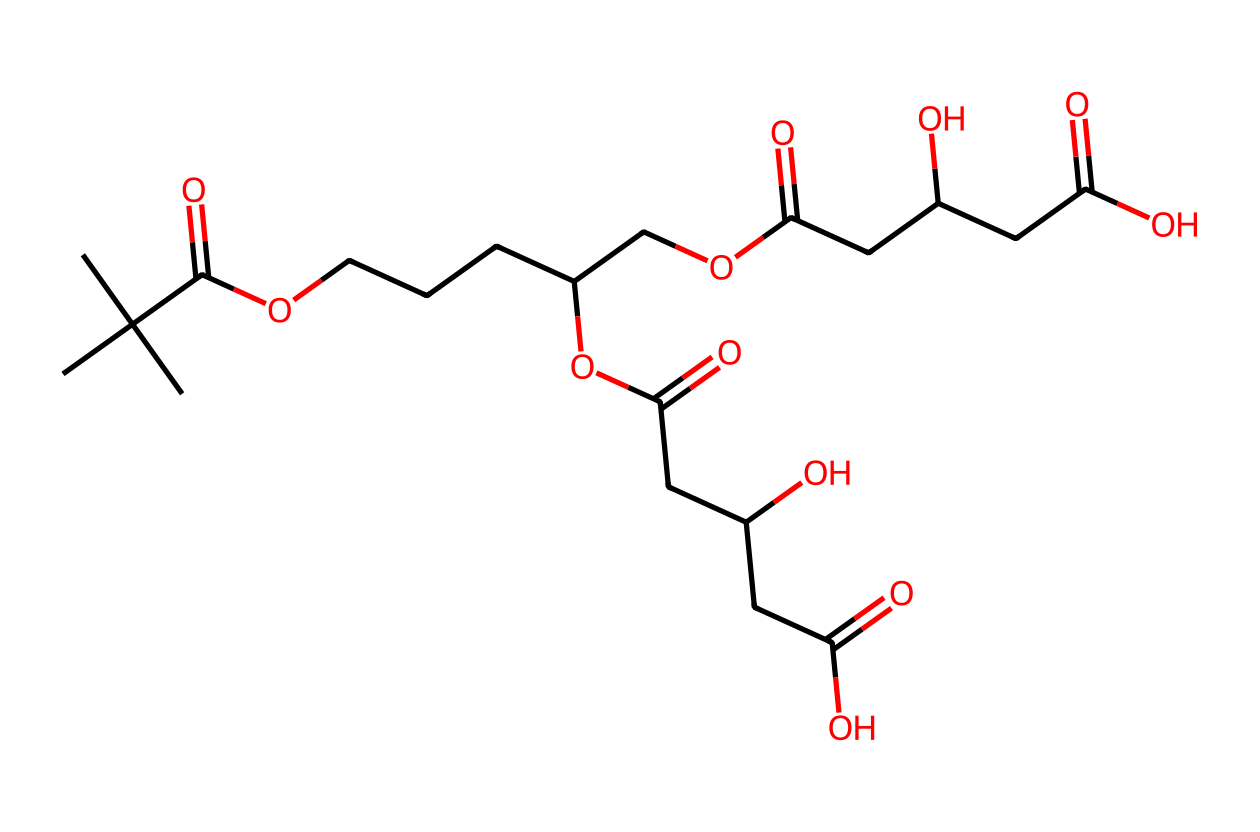What is the molecular formula deduced from the SMILES representation? To determine the molecular formula, count the number of carbon (C), hydrogen (H), and oxygen (O) atoms in the SMILES string. The structure indicates 36 carbons, 66 hydrogens, and 6 oxygens, leading to the formula C36H66O6.
Answer: C36H66O6 How many ester functional groups are present in the molecule? In the SMILES string, the ester groups are indicated by the presence of carbonyl (C=O) adjacent to an ether linkage (O). By examining the structure, there are three ester groups associated with the carbon chains.
Answer: 3 What type of lipid does this chemical represent? The structure shows long carbon chains with ester groups, characterizing it as a triglyceride, a common type of lipid.
Answer: triglyceride How many chiral centers are present in this lipid structure? Chiral centers are carbon atoms bound to four different substituents. Counting the chiral centers in the structure reveals there are four distinct chiral centers within the chains.
Answer: 4 What is the function of lipids in biodegradable packaging? Lipids serve as a hydrophobic barrier and enhance flexibility in packaging materials; they provide structure and stability while being environmentally friendly.
Answer: barrier Which part of the molecule contributes to its biodegradability? The presence of ester bonds and the backbone of long-chain fatty acids play a significant role in enabling microbial degradation, thus contributing to biodegradability.
Answer: ester bonds 